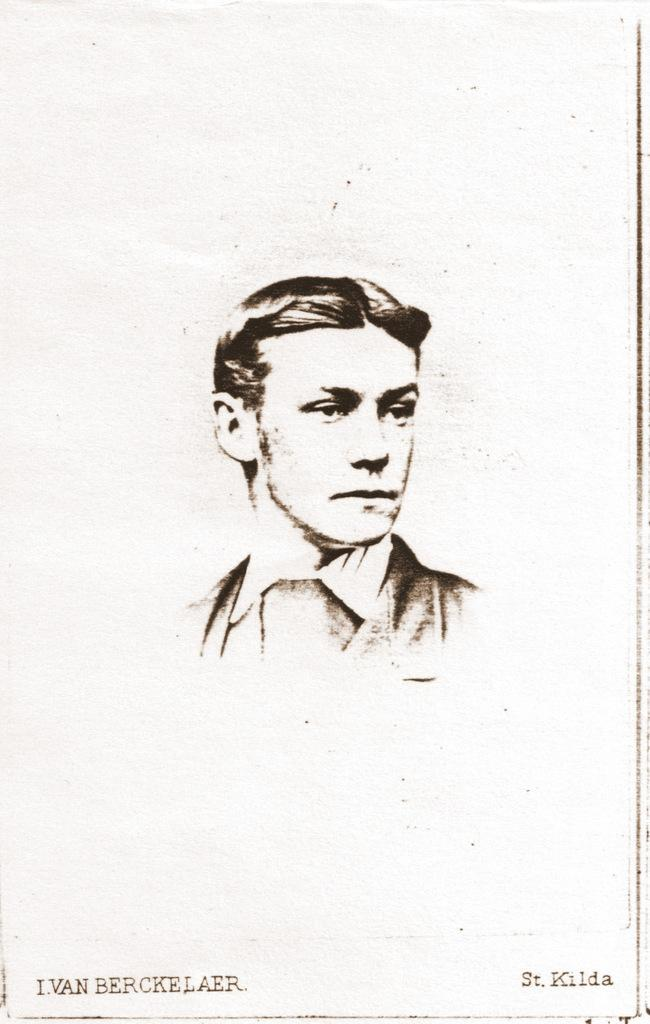What is present in the image that features an image and text? There is a poster in the image that contains an image and text. What type of image is on the poster? The poster contains an image of a man. Where is the box located in the image? There is no box present in the image. What type of bath is depicted in the image? There is no bath depicted in the image; it features a poster with an image of a man and text. 